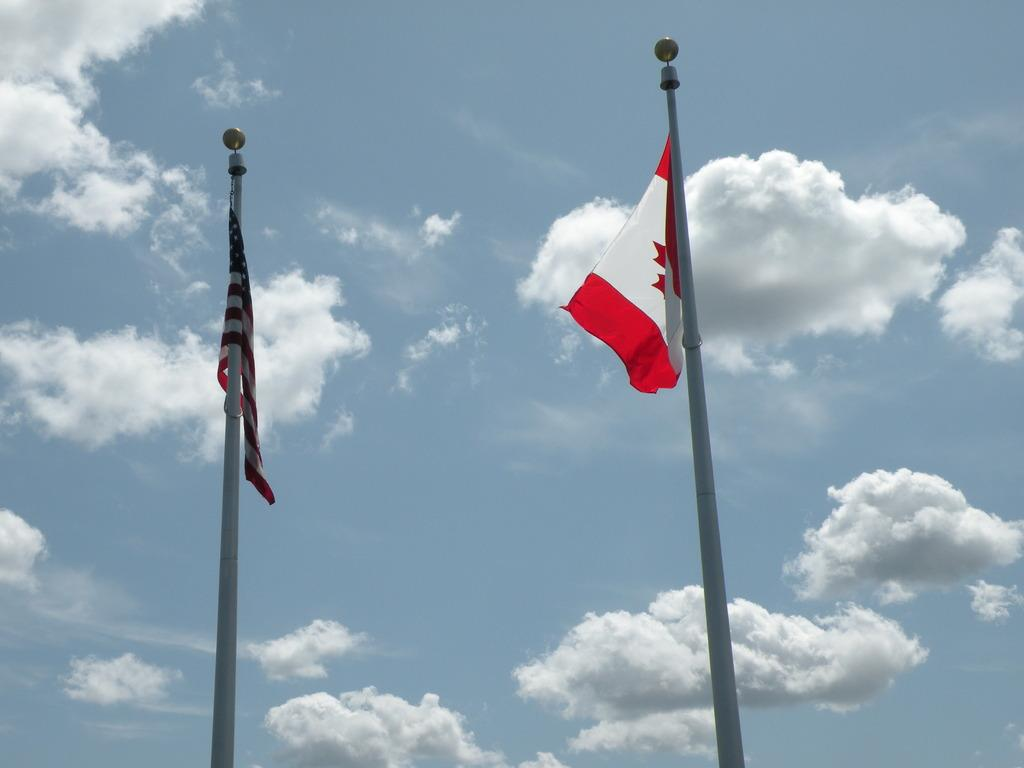What can be seen in the middle of the image? There are two poles in the middle of the image. What is attached to the poles? Flags are present on the poles. What is visible in the background of the image? There are clouds in the sky in the background of the image. How many gold legs can be seen supporting the poles in the image? There is no gold or legs present in the image; it features two poles with flags and a cloudy sky in the background. Is there a cobweb visible between the poles in the image? There is no cobweb present in the image; it only features two poles with flags and a cloudy sky in the background. 